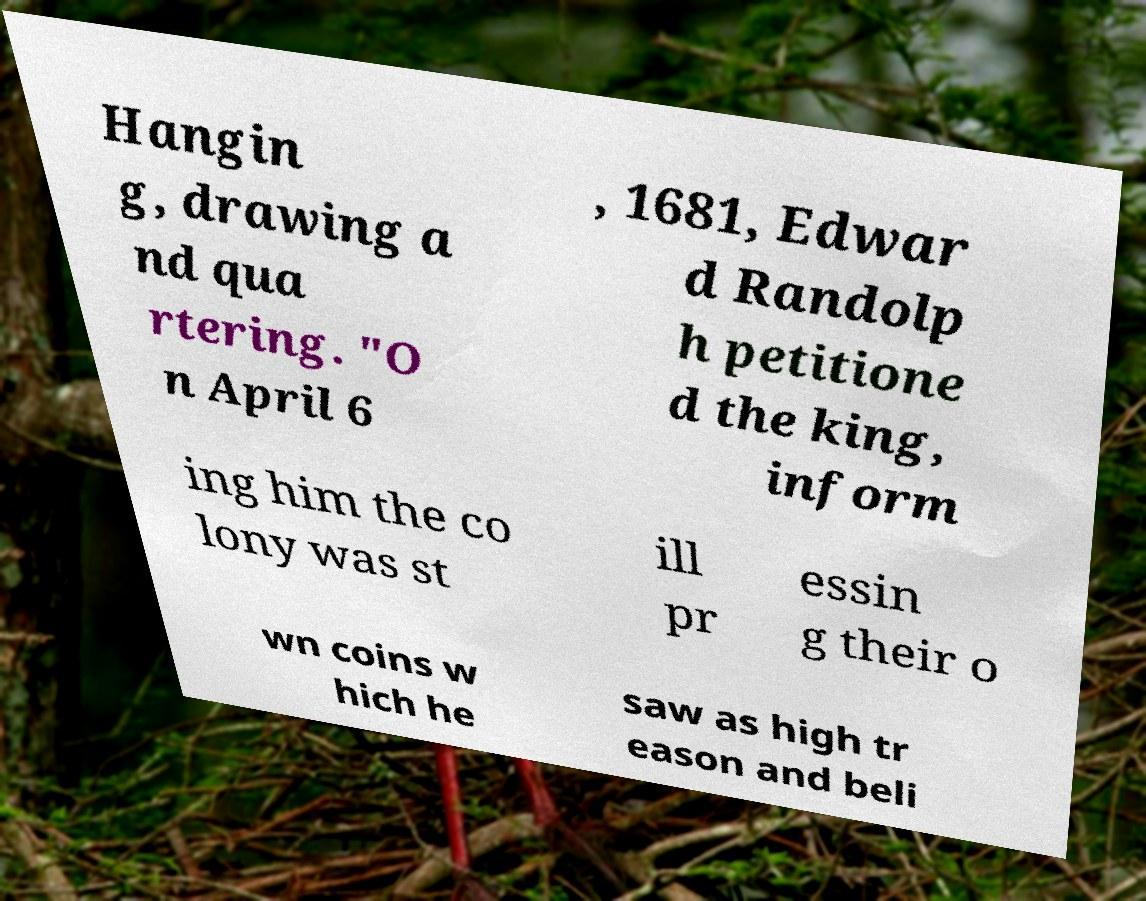Could you assist in decoding the text presented in this image and type it out clearly? Hangin g, drawing a nd qua rtering. "O n April 6 , 1681, Edwar d Randolp h petitione d the king, inform ing him the co lony was st ill pr essin g their o wn coins w hich he saw as high tr eason and beli 